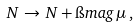Convert formula to latex. <formula><loc_0><loc_0><loc_500><loc_500>N \, \rightarrow \, N + \i m a g \, \mu \, ,</formula> 